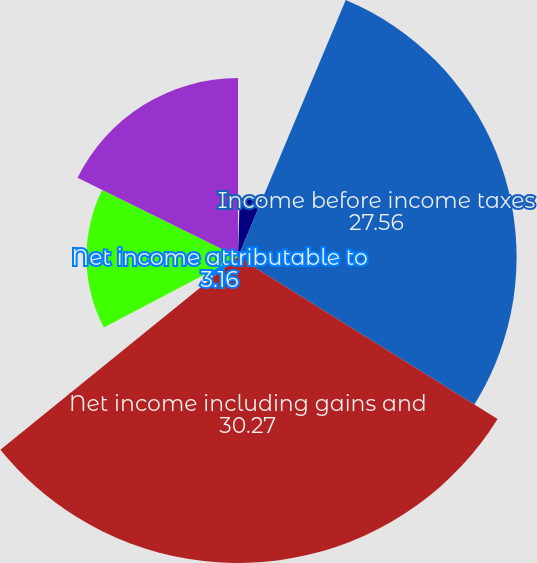<chart> <loc_0><loc_0><loc_500><loc_500><pie_chart><fcel>Total operating revenues<fcel>Total operating expenses<fcel>Income before income taxes<fcel>Net income including gains and<fcel>Net income attributable to<fcel>Income/(loss) before income<fcel>Net income/(loss) including<nl><fcel>0.45%<fcel>5.87%<fcel>27.56%<fcel>30.27%<fcel>3.16%<fcel>14.99%<fcel>17.7%<nl></chart> 